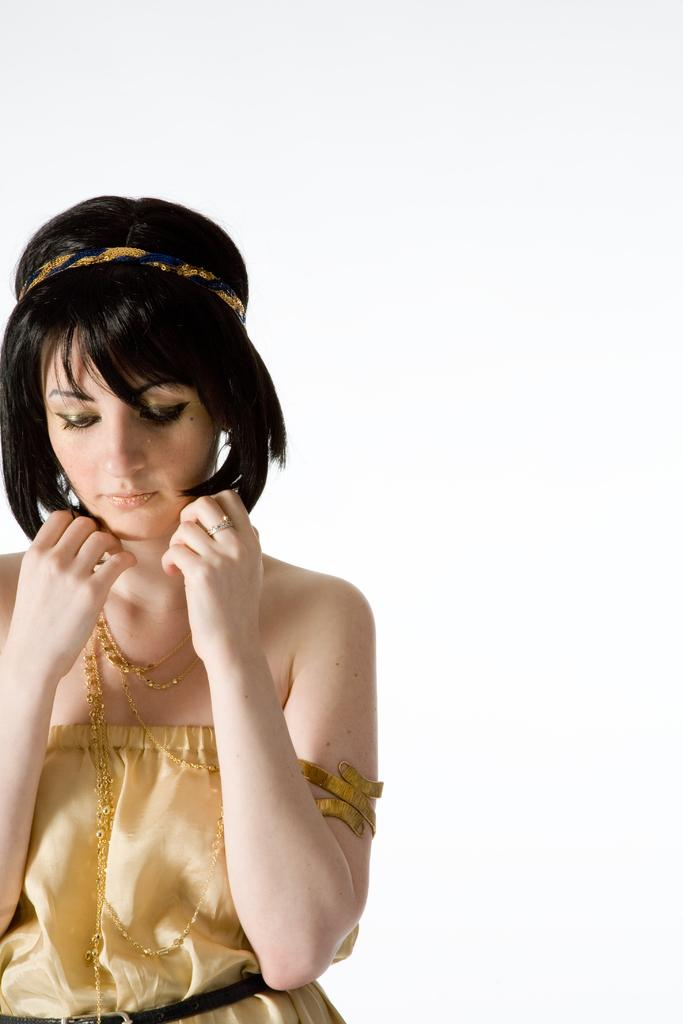What is the main subject of the image? There is a woman standing in the image. What is the woman wearing? The woman is wearing a dress and gold chains. Can you describe any accessories the woman is wearing? Yes, there is a headband visible in the image. What is the color of the background in the image? The background of the image is white in color. What type of jar is visible in the image? There is no jar present in the image. What sign does the woman hold in the image? There is no sign visible in the image. 